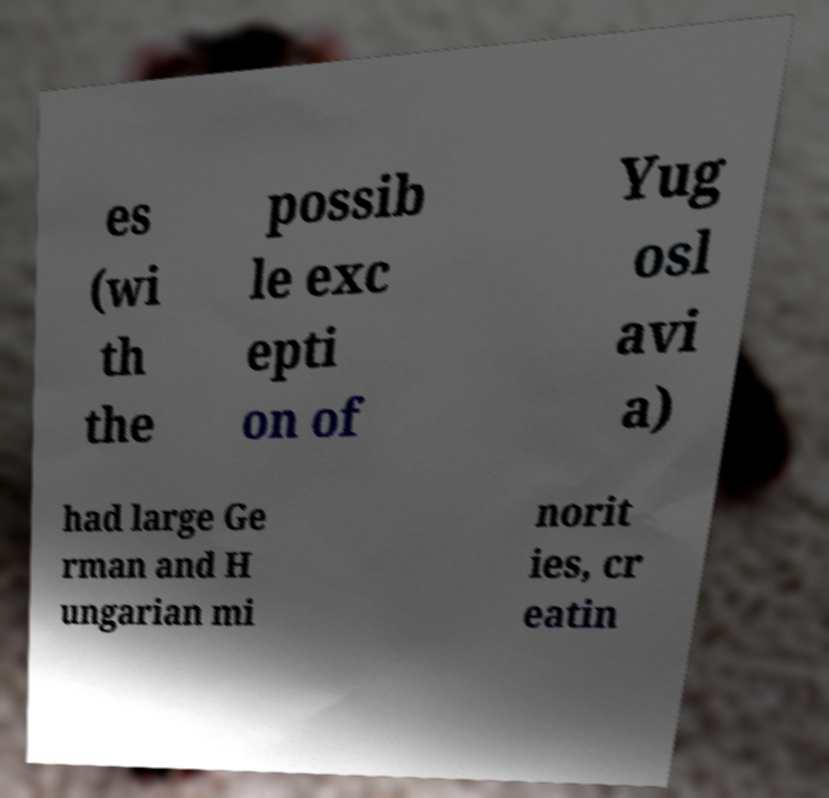What messages or text are displayed in this image? I need them in a readable, typed format. es (wi th the possib le exc epti on of Yug osl avi a) had large Ge rman and H ungarian mi norit ies, cr eatin 